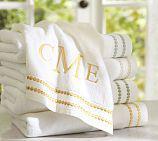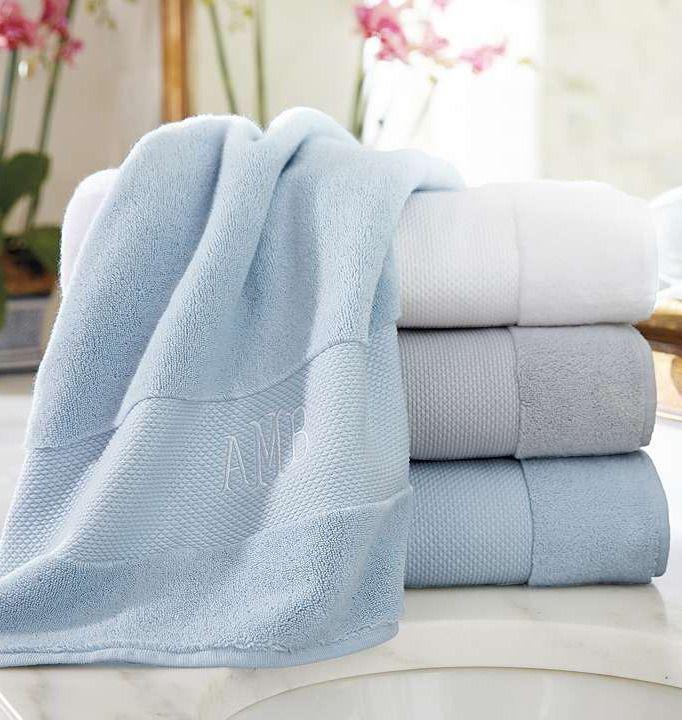The first image is the image on the left, the second image is the image on the right. For the images displayed, is the sentence "Each image shows lettered towels draped near a faucet." factually correct? Answer yes or no. No. 